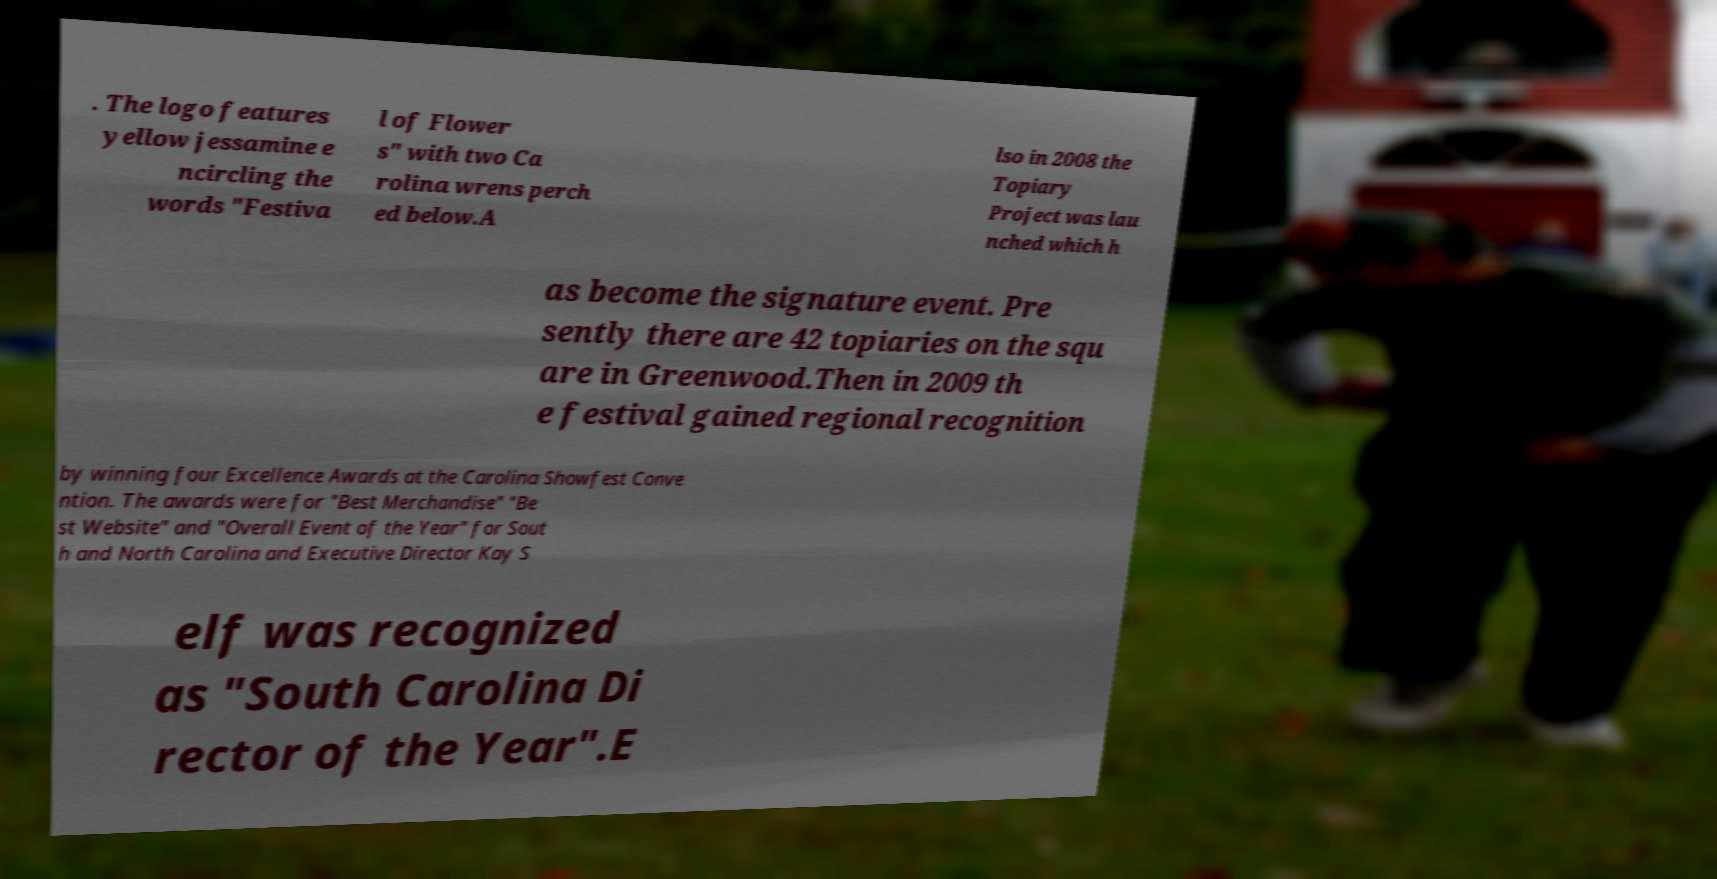For documentation purposes, I need the text within this image transcribed. Could you provide that? . The logo features yellow jessamine e ncircling the words "Festiva l of Flower s" with two Ca rolina wrens perch ed below.A lso in 2008 the Topiary Project was lau nched which h as become the signature event. Pre sently there are 42 topiaries on the squ are in Greenwood.Then in 2009 th e festival gained regional recognition by winning four Excellence Awards at the Carolina Showfest Conve ntion. The awards were for "Best Merchandise" "Be st Website" and "Overall Event of the Year" for Sout h and North Carolina and Executive Director Kay S elf was recognized as "South Carolina Di rector of the Year".E 